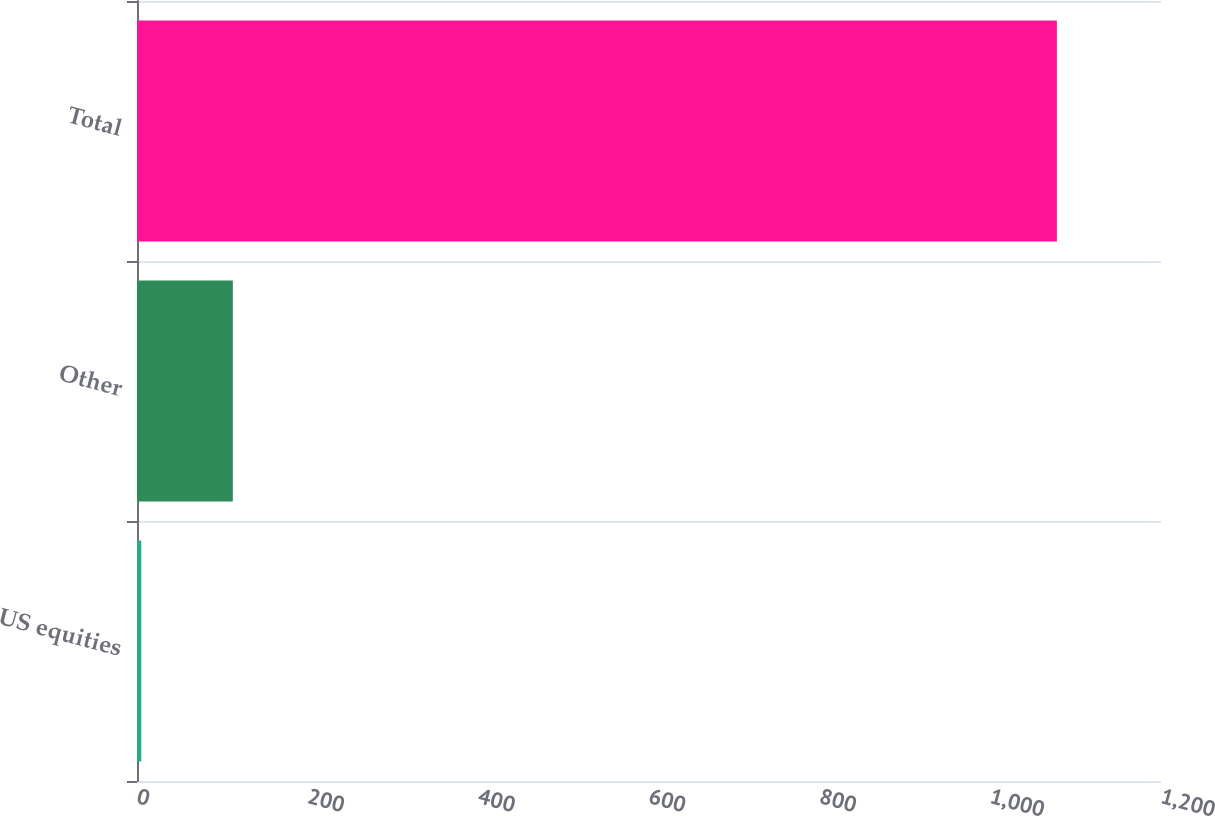<chart> <loc_0><loc_0><loc_500><loc_500><bar_chart><fcel>US equities<fcel>Other<fcel>Total<nl><fcel>5<fcel>112.3<fcel>1078<nl></chart> 